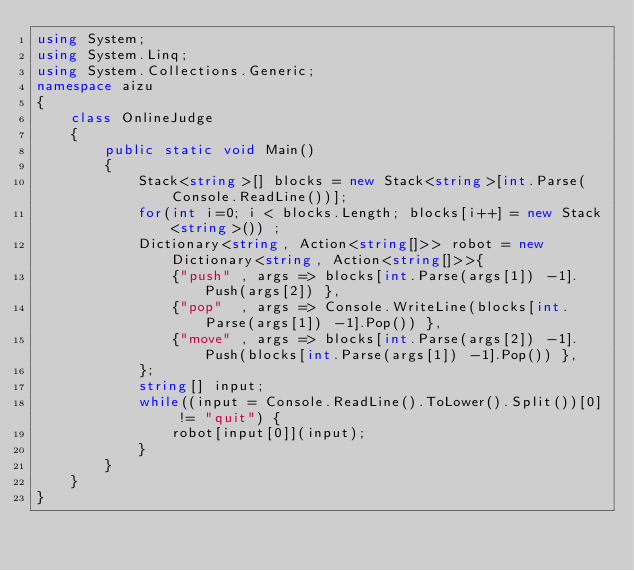<code> <loc_0><loc_0><loc_500><loc_500><_C#_>using System;
using System.Linq;
using System.Collections.Generic;
namespace aizu
{
    class OnlineJudge
    {
        public static void Main()
        {
            Stack<string>[] blocks = new Stack<string>[int.Parse(Console.ReadLine())];
            for(int i=0; i < blocks.Length; blocks[i++] = new Stack<string>()) ;
            Dictionary<string, Action<string[]>> robot = new Dictionary<string, Action<string[]>>{
                {"push" , args => blocks[int.Parse(args[1]) -1].Push(args[2]) },
                {"pop"  , args => Console.WriteLine(blocks[int.Parse(args[1]) -1].Pop()) },
                {"move" , args => blocks[int.Parse(args[2]) -1].Push(blocks[int.Parse(args[1]) -1].Pop()) },
            };
            string[] input;
            while((input = Console.ReadLine().ToLower().Split())[0] != "quit") {
                robot[input[0]](input);
            }
        }
    }
}</code> 